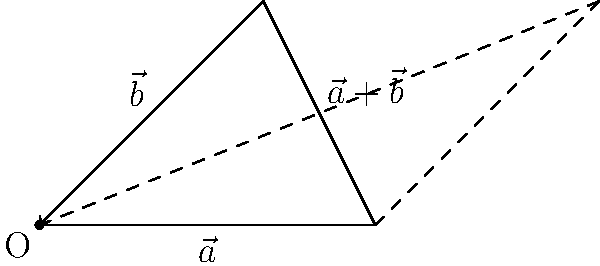In the parallelogram method of vector addition shown above, vectors $\vec{a}$ and $\vec{b}$ are represented by the sides of the parallelogram. If $|\vec{a}| = 3$ units and $|\vec{b}| = \sqrt{8}$ units, and the angle between them is 60°, what is the magnitude of the resultant vector $\vec{a}+\vec{b}$? To find the magnitude of the resultant vector $\vec{a}+\vec{b}$, we can use the law of cosines:

1) The law of cosines states: $c^2 = a^2 + b^2 - 2ab \cos\theta$
   Where $c$ is the magnitude of the resultant vector, $a$ and $b$ are the magnitudes of the component vectors, and $\theta$ is the angle between them.

2) We're given:
   $|\vec{a}| = a = 3$
   $|\vec{b}| = b = \sqrt{8}$
   $\theta = 60°$

3) Substituting into the formula:
   $c^2 = 3^2 + (\sqrt{8})^2 - 2(3)(\sqrt{8})\cos 60°$

4) Simplify:
   $c^2 = 9 + 8 - 6\sqrt{8} \cdot \frac{1}{2}$
   $c^2 = 17 - 3\sqrt{8}$

5) Take the square root of both sides:
   $c = \sqrt{17 - 3\sqrt{8}}$

This is the magnitude of the resultant vector $\vec{a}+\vec{b}$.
Answer: $\sqrt{17 - 3\sqrt{8}}$ units 